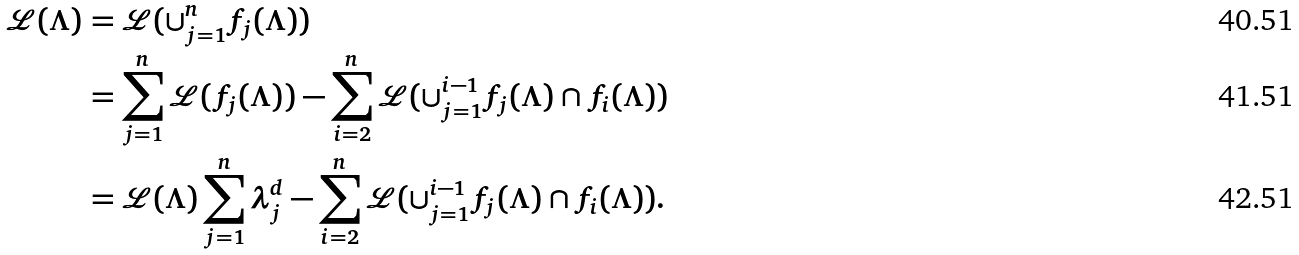<formula> <loc_0><loc_0><loc_500><loc_500>\mathcal { L } ( \Lambda ) & = \mathcal { L } ( \cup _ { j = 1 } ^ { n } f _ { j } ( \Lambda ) ) \\ & = \sum _ { j = 1 } ^ { n } \mathcal { L } ( f _ { j } ( \Lambda ) ) - \sum _ { i = 2 } ^ { n } \mathcal { L } ( \cup _ { j = 1 } ^ { i - 1 } f _ { j } ( \Lambda ) \cap f _ { i } ( \Lambda ) ) \\ & = \mathcal { L } ( \Lambda ) \sum _ { j = 1 } ^ { n } \lambda _ { j } ^ { d } - \sum _ { i = 2 } ^ { n } \mathcal { L } ( \cup _ { j = 1 } ^ { i - 1 } f _ { j } ( \Lambda ) \cap f _ { i } ( \Lambda ) ) .</formula> 